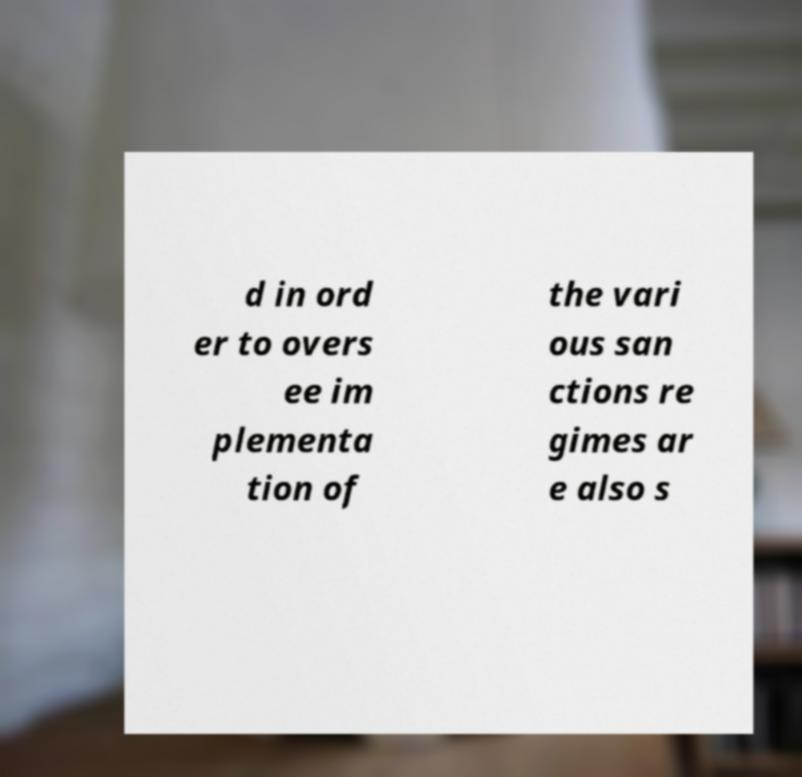What messages or text are displayed in this image? I need them in a readable, typed format. d in ord er to overs ee im plementa tion of the vari ous san ctions re gimes ar e also s 